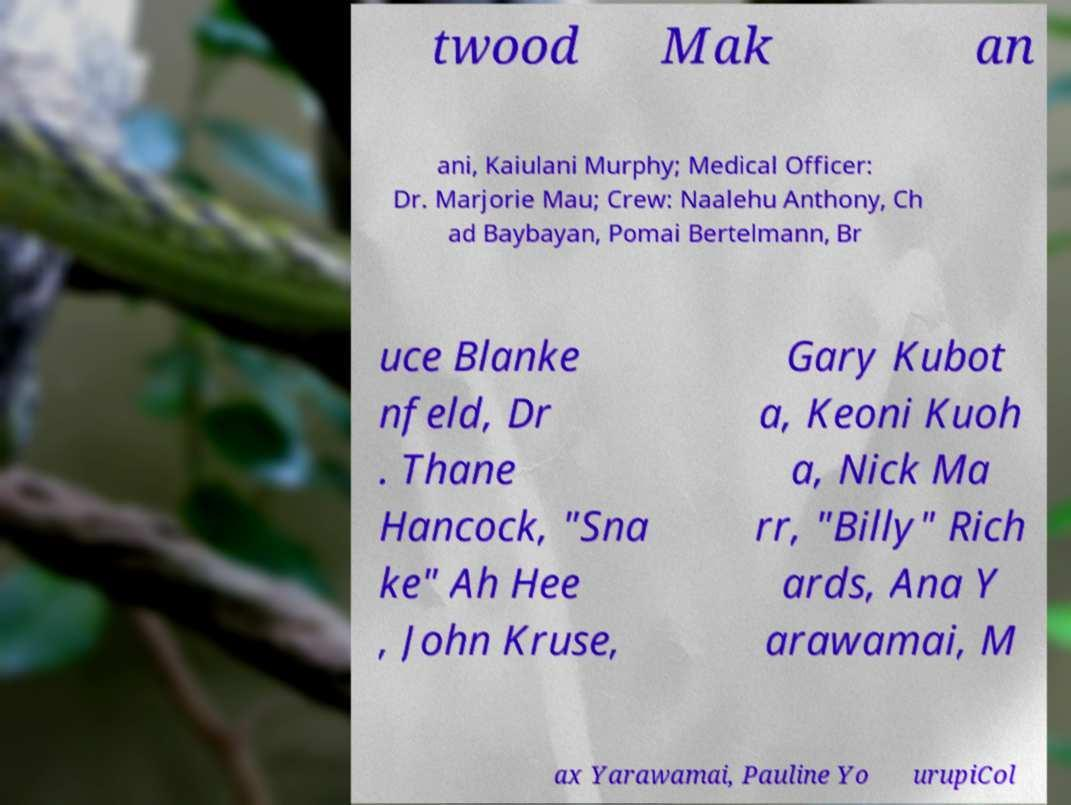There's text embedded in this image that I need extracted. Can you transcribe it verbatim? twood Mak an ani, Kaiulani Murphy; Medical Officer: Dr. Marjorie Mau; Crew: Naalehu Anthony, Ch ad Baybayan, Pomai Bertelmann, Br uce Blanke nfeld, Dr . Thane Hancock, "Sna ke" Ah Hee , John Kruse, Gary Kubot a, Keoni Kuoh a, Nick Ma rr, "Billy" Rich ards, Ana Y arawamai, M ax Yarawamai, Pauline Yo urupiCol 